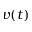<formula> <loc_0><loc_0><loc_500><loc_500>v ( t )</formula> 